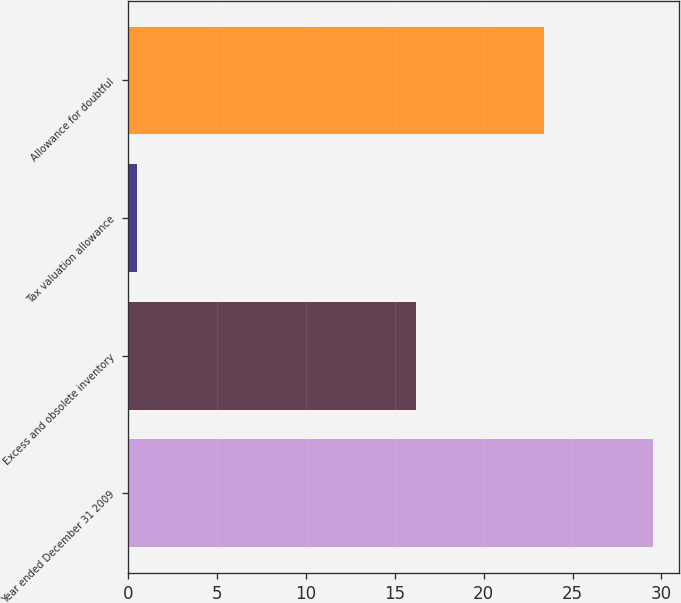Convert chart. <chart><loc_0><loc_0><loc_500><loc_500><bar_chart><fcel>Year ended December 31 2009<fcel>Excess and obsolete inventory<fcel>Tax valuation allowance<fcel>Allowance for doubtful<nl><fcel>29.5<fcel>16.2<fcel>0.5<fcel>23.4<nl></chart> 